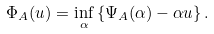Convert formula to latex. <formula><loc_0><loc_0><loc_500><loc_500>\Phi _ { A } ( u ) = \inf _ { \alpha } \left \{ \Psi _ { A } ( \alpha ) - \alpha u \right \} .</formula> 